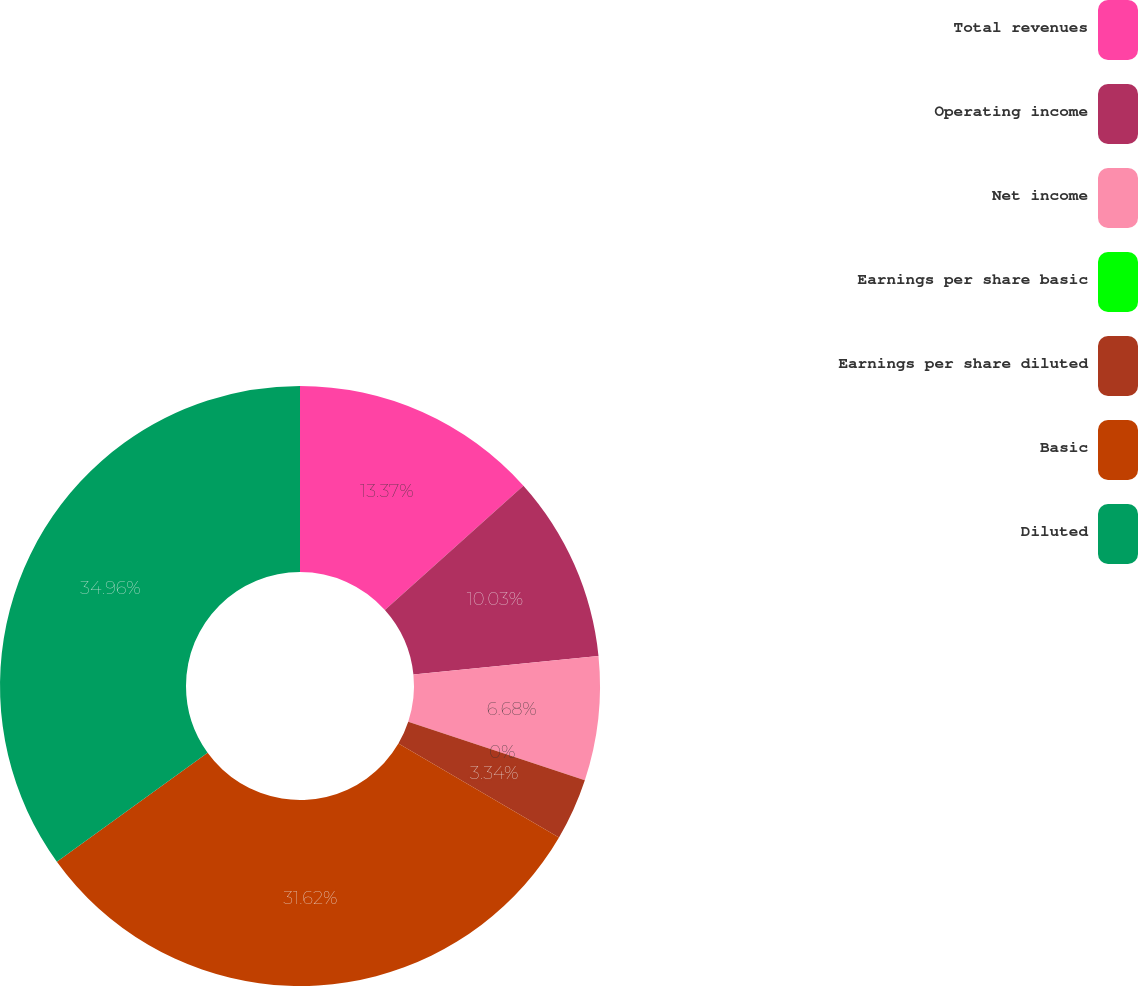<chart> <loc_0><loc_0><loc_500><loc_500><pie_chart><fcel>Total revenues<fcel>Operating income<fcel>Net income<fcel>Earnings per share basic<fcel>Earnings per share diluted<fcel>Basic<fcel>Diluted<nl><fcel>13.37%<fcel>10.03%<fcel>6.68%<fcel>0.0%<fcel>3.34%<fcel>31.62%<fcel>34.96%<nl></chart> 